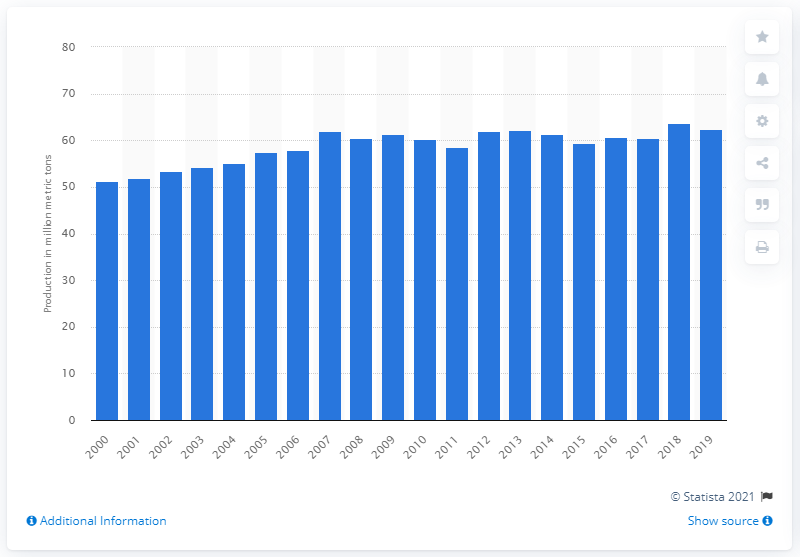List a handful of essential elements in this visual. According to data from 2019, global coconut production was 62.46 million metric tons. 